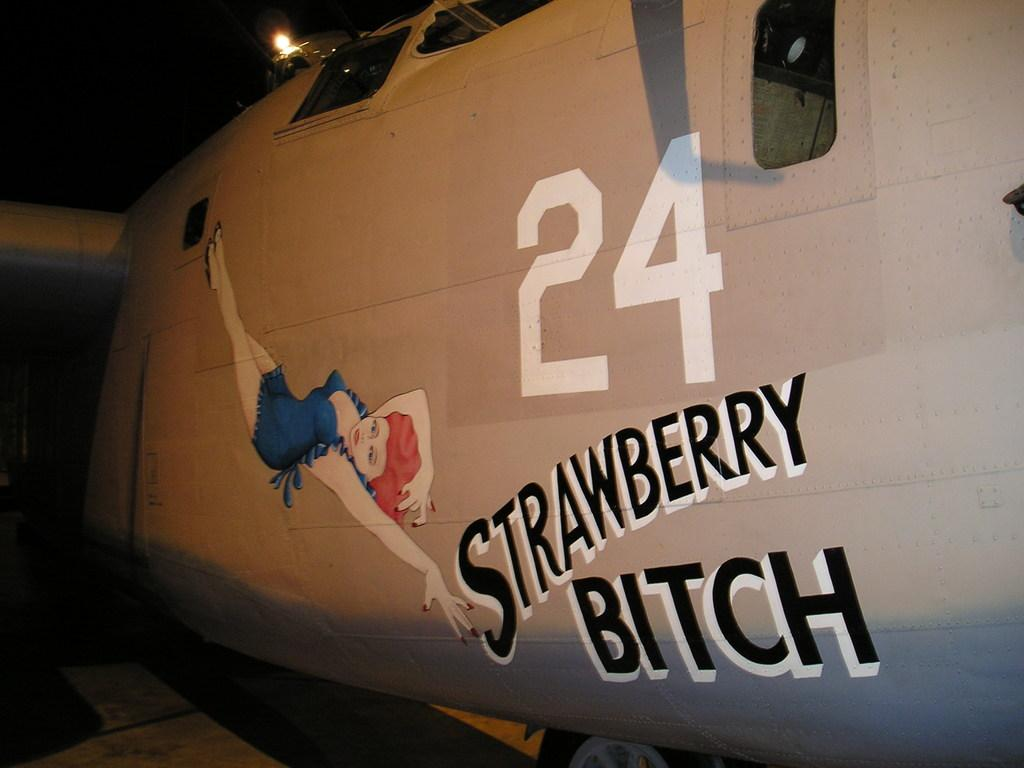<image>
Relay a brief, clear account of the picture shown. An airplane with the number 24 on it's side 